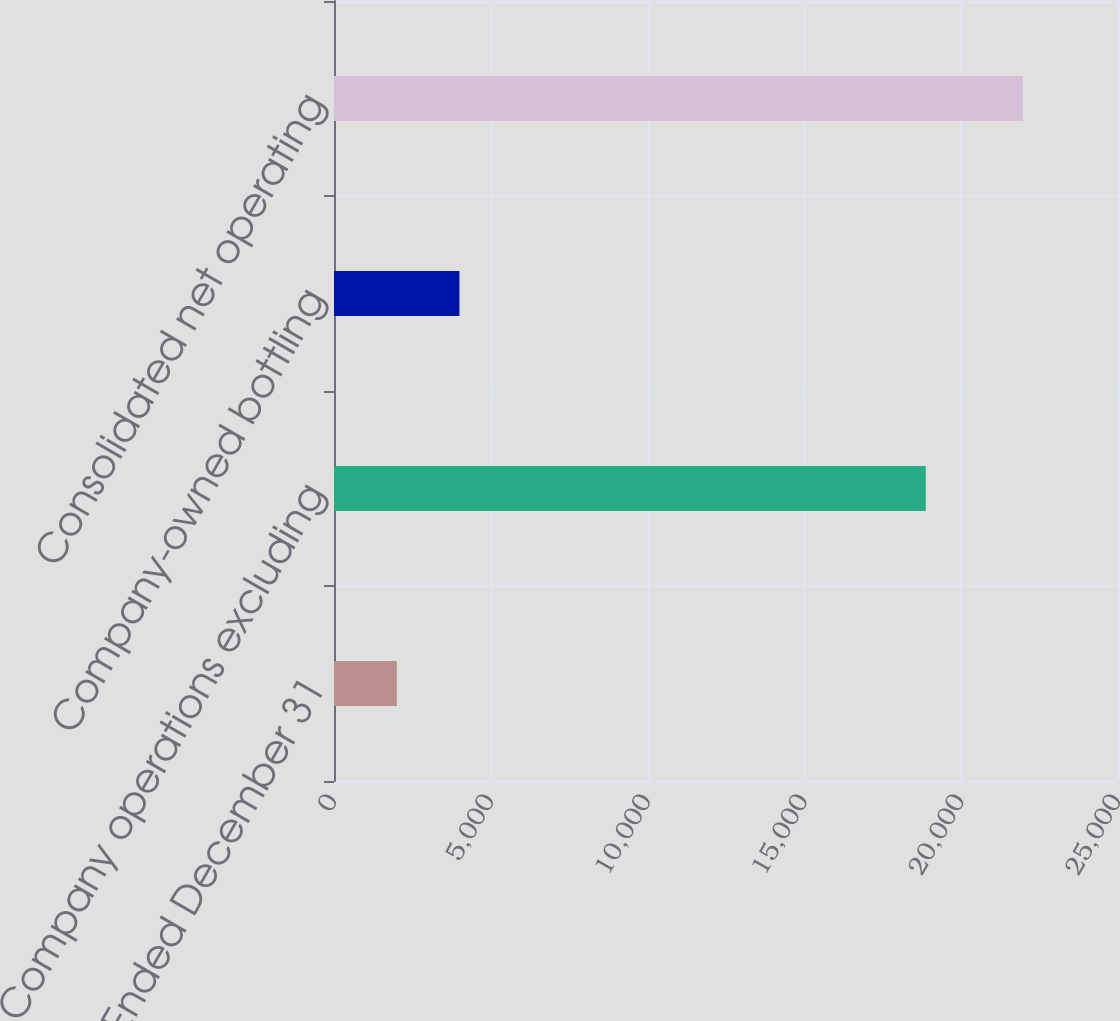<chart> <loc_0><loc_0><loc_500><loc_500><bar_chart><fcel>Year Ended December 31<fcel>Company operations excluding<fcel>Company-owned bottling<fcel>Consolidated net operating<nl><fcel>2004<fcel>18871<fcel>3999.8<fcel>21962<nl></chart> 